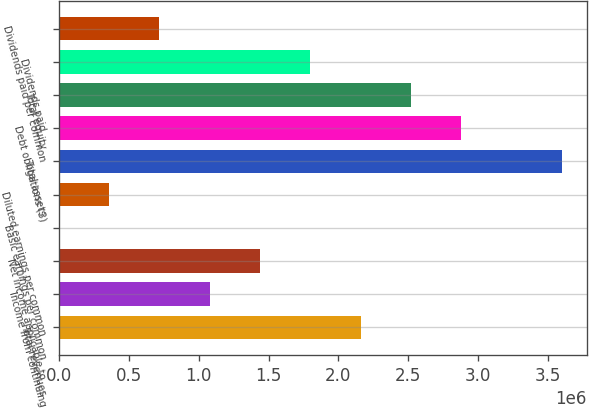<chart> <loc_0><loc_0><loc_500><loc_500><bar_chart><fcel>Total revenues<fcel>Income from continuing<fcel>Net income applicable to<fcel>Basic earnings per common<fcel>Diluted earnings per common<fcel>Total assets<fcel>Debt obligations (3)<fcel>Total equity<fcel>Dividends paid<fcel>Dividends paid per common<nl><fcel>2.15836e+06<fcel>1.07918e+06<fcel>1.43891e+06<fcel>0.17<fcel>359727<fcel>3.59726e+06<fcel>2.87781e+06<fcel>2.51809e+06<fcel>1.79863e+06<fcel>719453<nl></chart> 